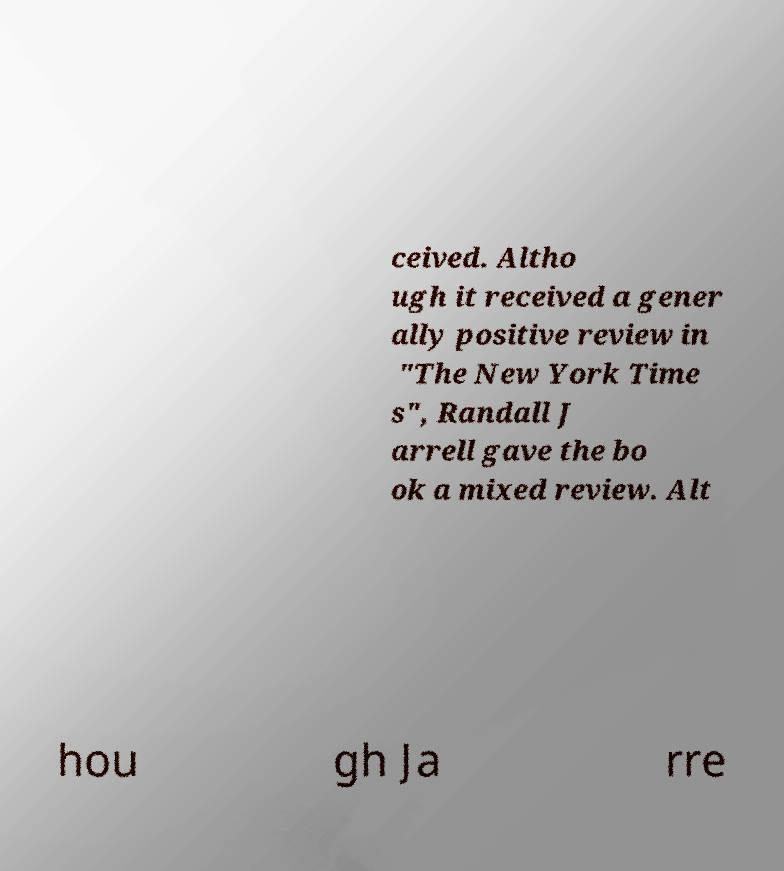Could you assist in decoding the text presented in this image and type it out clearly? ceived. Altho ugh it received a gener ally positive review in "The New York Time s", Randall J arrell gave the bo ok a mixed review. Alt hou gh Ja rre 